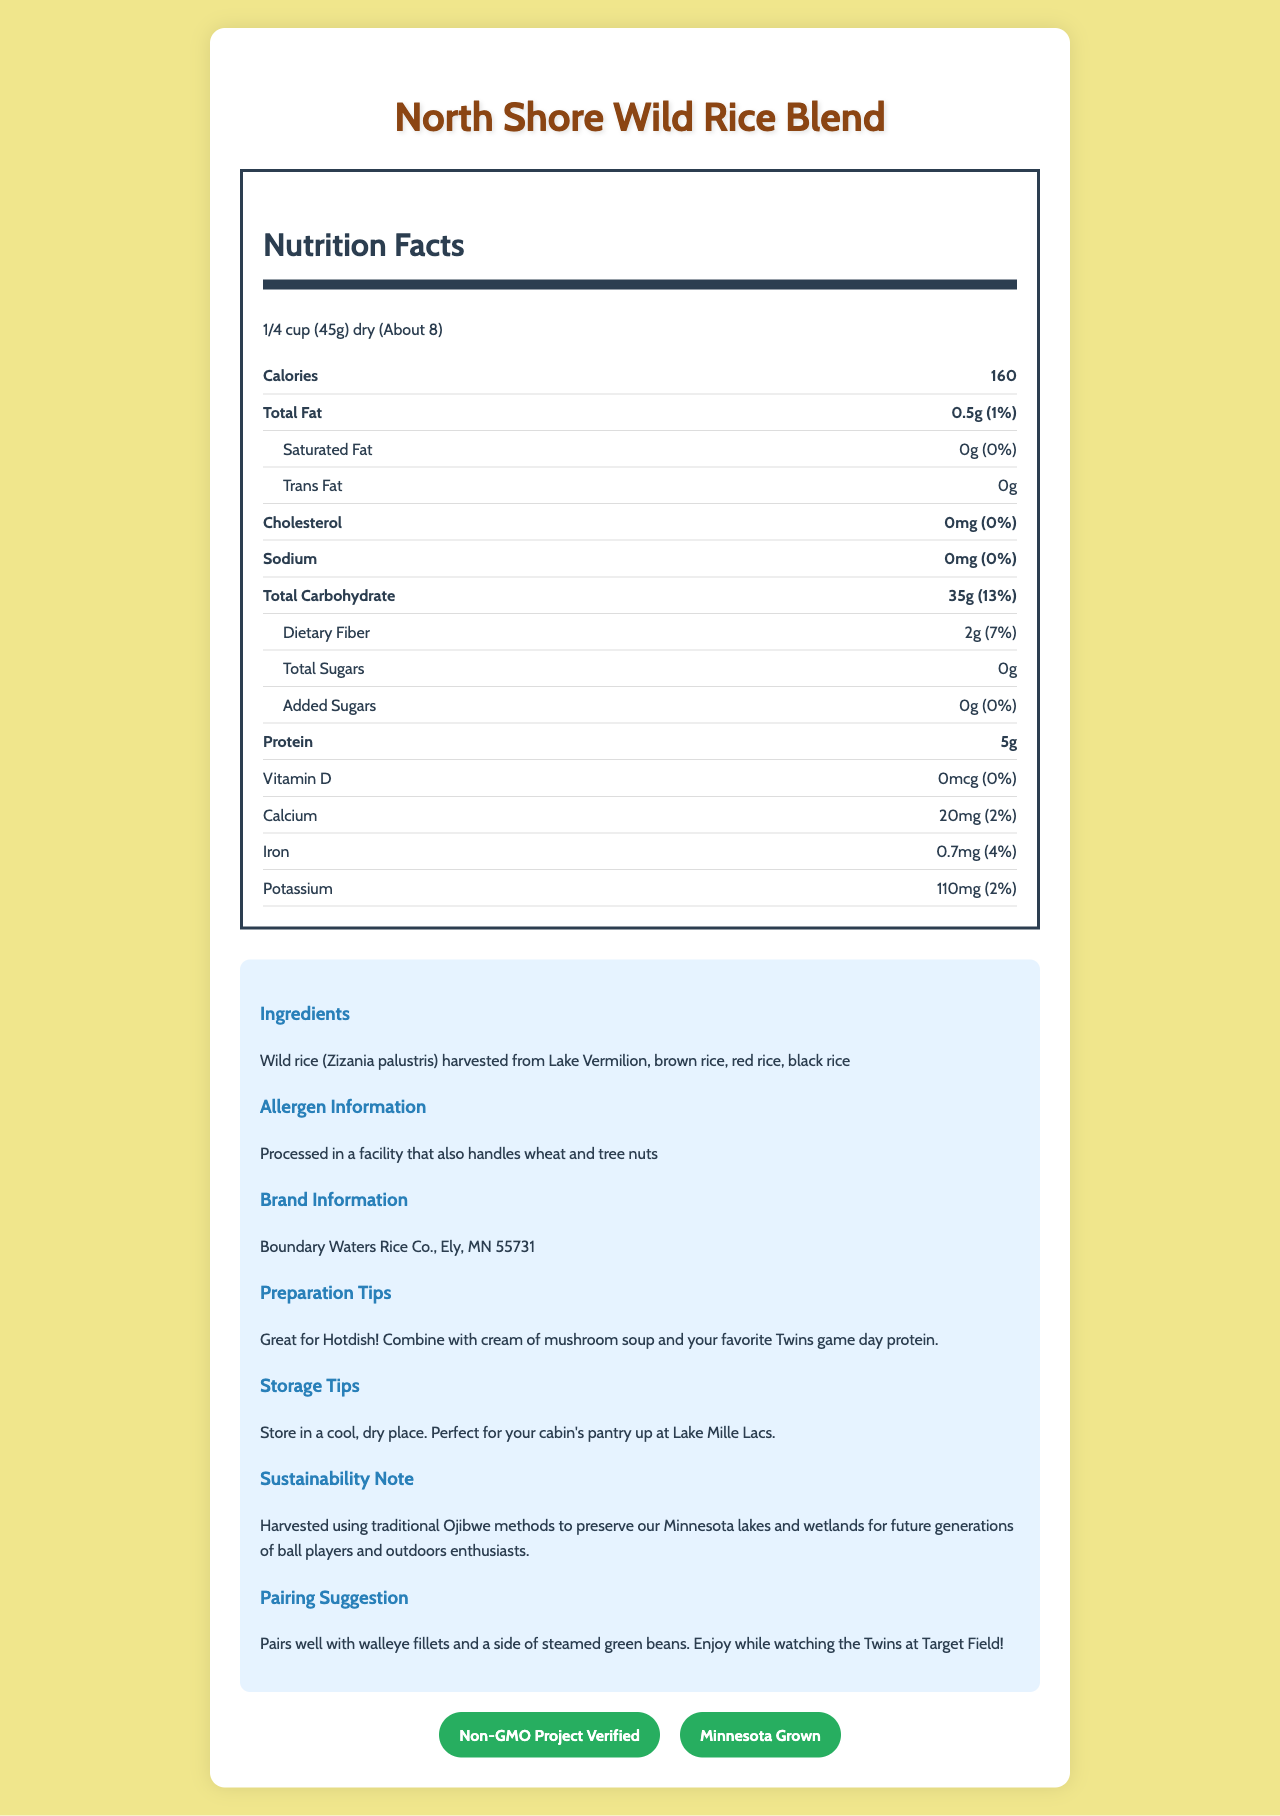what is the serving size for the North Shore Wild Rice Blend? The serving size is stated directly under the product name in the document.
Answer: 1/4 cup (45g) dry how many servings are there per container? The servings per container are mentioned directly under the serving size information.
Answer: About 8 How many calories are in one serving? The number of calories per serving is listed right at the top of the nutrition facts section.
Answer: 160 What is the total fat content per serving? The total fat content per serving is specified under the "Total Fat" section.
Answer: 0.5g What is the amount of dietary fiber per serving? The amount of dietary fiber per serving is mentioned under the "Dietary Fiber" section.
Answer: 2g How much iron does one serving contain? The iron content is listed under the vitamin and mineral section.
Answer: 0.7mg What is the preparation tip provided for the wild rice blend? The preparation tip is located in the "Preparation Tips" section of the document.
Answer: Combine with cream of mushroom soup and your favorite Twins game day protein Which of the following nutrients has 0% of the daily value per serving? A. Saturated Fat B. Dietary Fiber C. Sodium D. Calcium Saturated Fat has 0%, as listed under the "Saturated Fat" section.
Answer: A. Saturated Fat What allergen information is provided for this wild rice blend? A. Contains Soy B. Contains Dairy C. Processed in a facility that handles wheat and tree nuts D. Contains Peanuts The allergen information is clearly mentioned under the "Allergen Information" section.
Answer: C. Processed in a facility that handles wheat and tree nuts What certification does the North Shore Wild Rice Blend have? The certifications are displayed at the bottom of the document under the "certifications" section.
Answer: Non-GMO Project Verified and Minnesota Grown Is this wild rice blend processed in a facility that also handles allergens such as tree nuts and wheat? The allergen information states that it's processed in a facility that handles wheat and tree nuts.
Answer: Yes Summarize the main idea of the document. This summary captures the overarching details present in different sections of the document.
Answer: The document provides nutritional information, ingredients, allergen details, brand information, and preparation/storage tips for North Shore Wild Rice Blend, a locally-sourced, non-GMO product from Minnesota. What is the exact amount of sodium in one serving of the North Shore Wild Rice Blend? The sodium content is zero, which is mentioned under the "Sodium" section.
Answer: 0mg How should the wild rice blend be stored? The storage information recommends keeping the product in a cool, dry place.
Answer: Store in a cool, dry place Which of the following is not an ingredient in the North Shore Wild Rice Blend? A. Black Rice B. Brown Rice C. White Rice D. Red Rice The ingredients listed are wild rice, brown rice, red rice, and black rice. White rice is not included.
Answer: C. White Rice Describe the company's approach to sustainability. The sustainability note mentions that traditional Ojibwe methods are used for harvesting to protect the environment.
Answer: Harvested using traditional Ojibwe methods to preserve Minnesota lakes and wetlands for future generations. What pairing suggestion is provided? The pairing suggestion is mentioned under the "Pairing Suggestion" section.
Answer: Pairs well with walleye fillets and a side of steamed green beans. Enjoy while watching the Twins at Target Field! How much protein does one serving of the North Shore Wild Rice Blend contain? The protein content per serving is listed directly under the "Protein" section.
Answer: 5g 